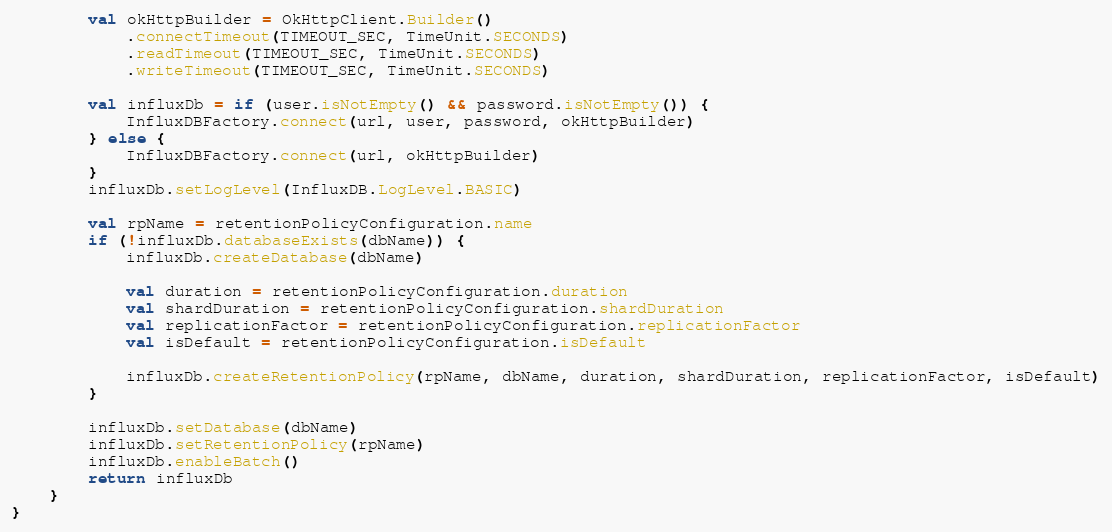<code> <loc_0><loc_0><loc_500><loc_500><_Kotlin_>        val okHttpBuilder = OkHttpClient.Builder()
            .connectTimeout(TIMEOUT_SEC, TimeUnit.SECONDS)
            .readTimeout(TIMEOUT_SEC, TimeUnit.SECONDS)
            .writeTimeout(TIMEOUT_SEC, TimeUnit.SECONDS)

        val influxDb = if (user.isNotEmpty() && password.isNotEmpty()) {
            InfluxDBFactory.connect(url, user, password, okHttpBuilder)
        } else {
            InfluxDBFactory.connect(url, okHttpBuilder)
        }
        influxDb.setLogLevel(InfluxDB.LogLevel.BASIC)

        val rpName = retentionPolicyConfiguration.name
        if (!influxDb.databaseExists(dbName)) {
            influxDb.createDatabase(dbName)

            val duration = retentionPolicyConfiguration.duration
            val shardDuration = retentionPolicyConfiguration.shardDuration
            val replicationFactor = retentionPolicyConfiguration.replicationFactor
            val isDefault = retentionPolicyConfiguration.isDefault

            influxDb.createRetentionPolicy(rpName, dbName, duration, shardDuration, replicationFactor, isDefault)
        }

        influxDb.setDatabase(dbName)
        influxDb.setRetentionPolicy(rpName)
        influxDb.enableBatch()
        return influxDb
    }
}
</code> 